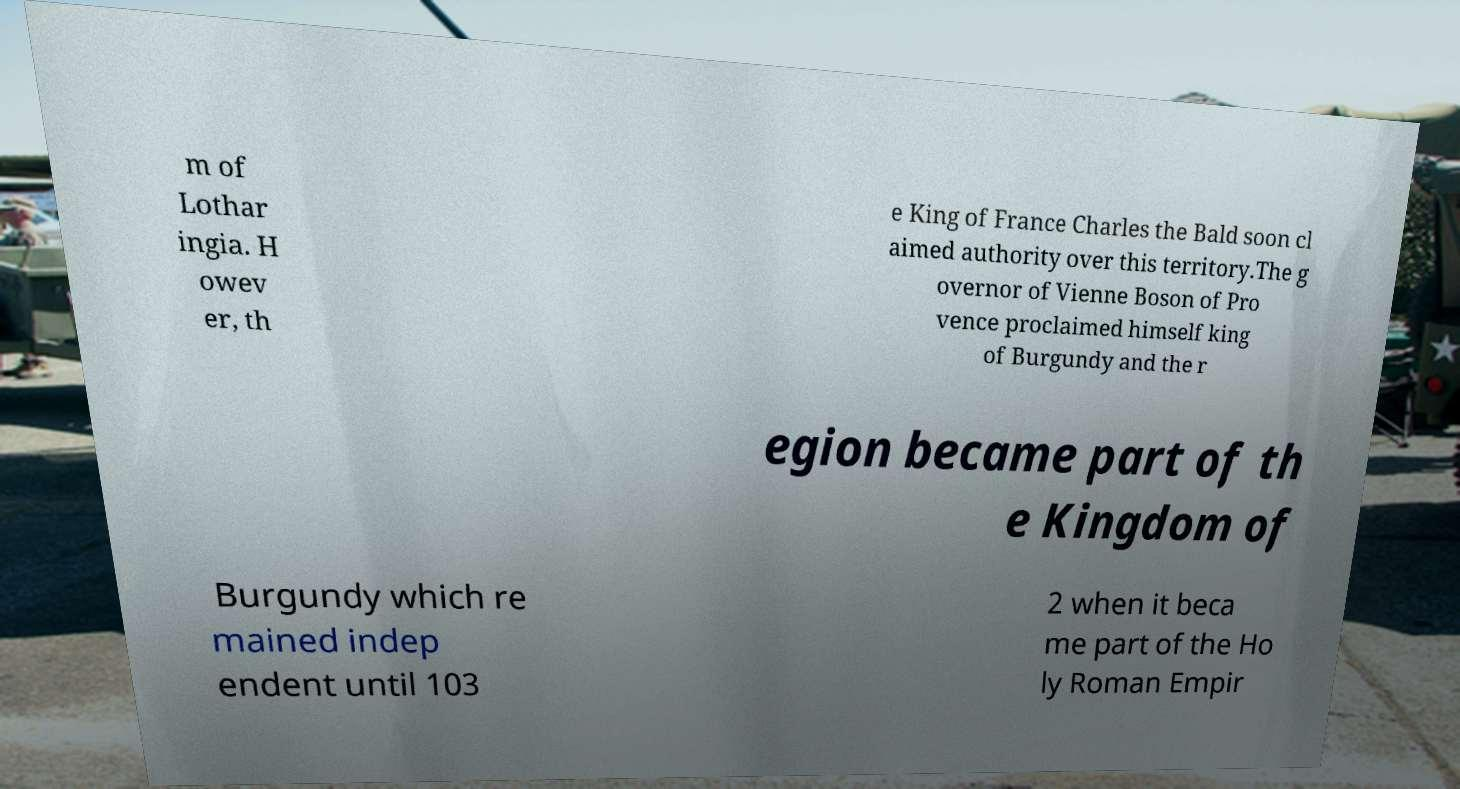Can you accurately transcribe the text from the provided image for me? m of Lothar ingia. H owev er, th e King of France Charles the Bald soon cl aimed authority over this territory.The g overnor of Vienne Boson of Pro vence proclaimed himself king of Burgundy and the r egion became part of th e Kingdom of Burgundy which re mained indep endent until 103 2 when it beca me part of the Ho ly Roman Empir 